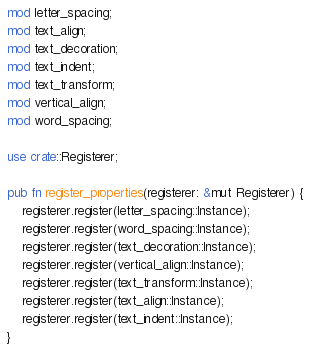Convert code to text. <code><loc_0><loc_0><loc_500><loc_500><_Rust_>mod letter_spacing;
mod text_align;
mod text_decoration;
mod text_indent;
mod text_transform;
mod vertical_align;
mod word_spacing;

use crate::Registerer;

pub fn register_properties(registerer: &mut Registerer) {
    registerer.register(letter_spacing::Instance);
    registerer.register(word_spacing::Instance);
    registerer.register(text_decoration::Instance);
    registerer.register(vertical_align::Instance);
    registerer.register(text_transform::Instance);
    registerer.register(text_align::Instance);
    registerer.register(text_indent::Instance);
}
</code> 